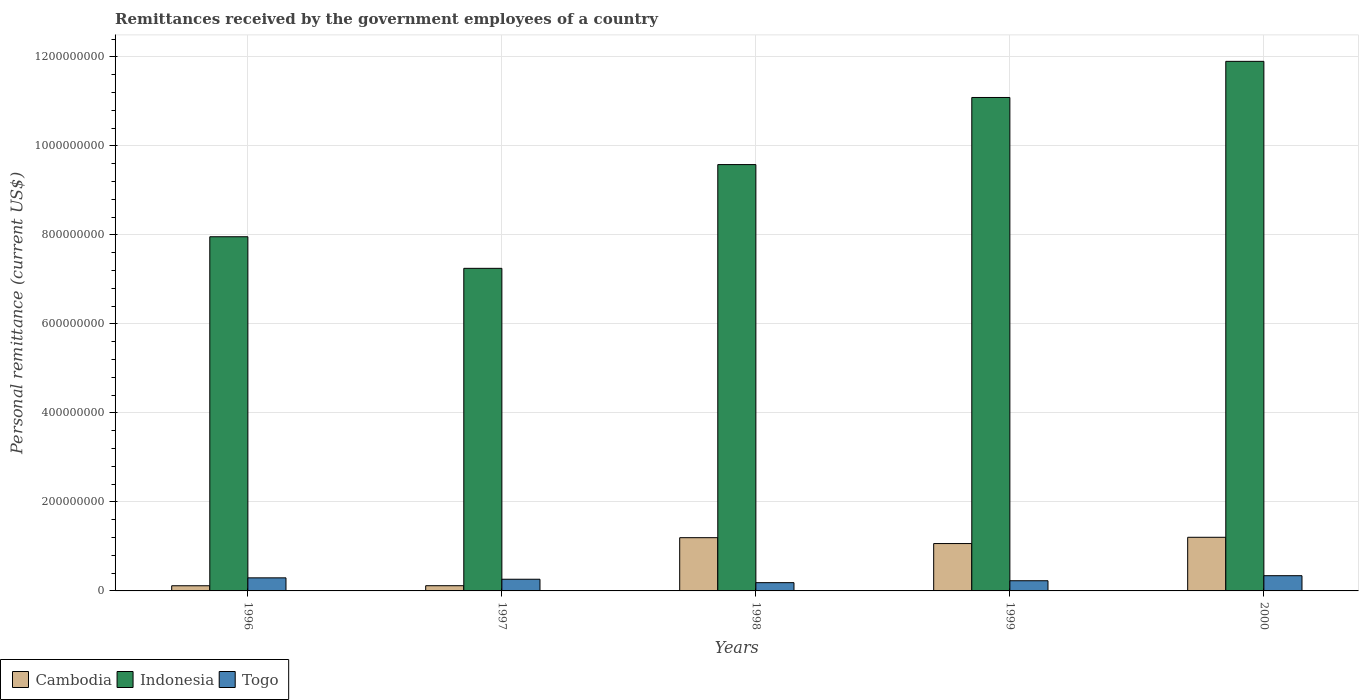How many groups of bars are there?
Offer a terse response. 5. Are the number of bars on each tick of the X-axis equal?
Make the answer very short. Yes. How many bars are there on the 3rd tick from the right?
Your answer should be compact. 3. What is the label of the 1st group of bars from the left?
Make the answer very short. 1996. In how many cases, is the number of bars for a given year not equal to the number of legend labels?
Keep it short and to the point. 0. What is the remittances received by the government employees in Togo in 1996?
Your response must be concise. 2.94e+07. Across all years, what is the maximum remittances received by the government employees in Togo?
Make the answer very short. 3.42e+07. Across all years, what is the minimum remittances received by the government employees in Indonesia?
Your answer should be very brief. 7.25e+08. What is the total remittances received by the government employees in Togo in the graph?
Your response must be concise. 1.31e+08. What is the difference between the remittances received by the government employees in Cambodia in 1996 and that in 1999?
Keep it short and to the point. -9.48e+07. What is the difference between the remittances received by the government employees in Togo in 1998 and the remittances received by the government employees in Cambodia in 1999?
Ensure brevity in your answer.  -8.79e+07. What is the average remittances received by the government employees in Cambodia per year?
Make the answer very short. 7.40e+07. In the year 1997, what is the difference between the remittances received by the government employees in Cambodia and remittances received by the government employees in Togo?
Offer a terse response. -1.46e+07. In how many years, is the remittances received by the government employees in Togo greater than 1160000000 US$?
Offer a very short reply. 0. What is the ratio of the remittances received by the government employees in Togo in 1996 to that in 1999?
Provide a succinct answer. 1.28. Is the remittances received by the government employees in Togo in 1999 less than that in 2000?
Offer a very short reply. Yes. What is the difference between the highest and the second highest remittances received by the government employees in Togo?
Offer a very short reply. 4.86e+06. What is the difference between the highest and the lowest remittances received by the government employees in Cambodia?
Offer a very short reply. 1.09e+08. Is the sum of the remittances received by the government employees in Cambodia in 1996 and 2000 greater than the maximum remittances received by the government employees in Togo across all years?
Offer a very short reply. Yes. What does the 3rd bar from the right in 1999 represents?
Provide a succinct answer. Cambodia. How many years are there in the graph?
Your answer should be compact. 5. Are the values on the major ticks of Y-axis written in scientific E-notation?
Offer a terse response. No. Does the graph contain any zero values?
Your answer should be very brief. No. How many legend labels are there?
Offer a very short reply. 3. How are the legend labels stacked?
Give a very brief answer. Horizontal. What is the title of the graph?
Give a very brief answer. Remittances received by the government employees of a country. Does "Iceland" appear as one of the legend labels in the graph?
Offer a terse response. No. What is the label or title of the Y-axis?
Offer a terse response. Personal remittance (current US$). What is the Personal remittance (current US$) of Cambodia in 1996?
Make the answer very short. 1.16e+07. What is the Personal remittance (current US$) in Indonesia in 1996?
Your response must be concise. 7.96e+08. What is the Personal remittance (current US$) in Togo in 1996?
Your answer should be compact. 2.94e+07. What is the Personal remittance (current US$) of Cambodia in 1997?
Provide a succinct answer. 1.17e+07. What is the Personal remittance (current US$) in Indonesia in 1997?
Your answer should be very brief. 7.25e+08. What is the Personal remittance (current US$) of Togo in 1997?
Offer a very short reply. 2.63e+07. What is the Personal remittance (current US$) of Cambodia in 1998?
Ensure brevity in your answer.  1.20e+08. What is the Personal remittance (current US$) of Indonesia in 1998?
Make the answer very short. 9.58e+08. What is the Personal remittance (current US$) in Togo in 1998?
Your answer should be very brief. 1.86e+07. What is the Personal remittance (current US$) of Cambodia in 1999?
Your answer should be very brief. 1.06e+08. What is the Personal remittance (current US$) of Indonesia in 1999?
Keep it short and to the point. 1.11e+09. What is the Personal remittance (current US$) in Togo in 1999?
Your answer should be compact. 2.29e+07. What is the Personal remittance (current US$) in Cambodia in 2000?
Provide a succinct answer. 1.21e+08. What is the Personal remittance (current US$) of Indonesia in 2000?
Your response must be concise. 1.19e+09. What is the Personal remittance (current US$) of Togo in 2000?
Ensure brevity in your answer.  3.42e+07. Across all years, what is the maximum Personal remittance (current US$) of Cambodia?
Your answer should be compact. 1.21e+08. Across all years, what is the maximum Personal remittance (current US$) in Indonesia?
Provide a succinct answer. 1.19e+09. Across all years, what is the maximum Personal remittance (current US$) of Togo?
Give a very brief answer. 3.42e+07. Across all years, what is the minimum Personal remittance (current US$) of Cambodia?
Ensure brevity in your answer.  1.16e+07. Across all years, what is the minimum Personal remittance (current US$) in Indonesia?
Provide a succinct answer. 7.25e+08. Across all years, what is the minimum Personal remittance (current US$) in Togo?
Offer a very short reply. 1.86e+07. What is the total Personal remittance (current US$) of Cambodia in the graph?
Keep it short and to the point. 3.70e+08. What is the total Personal remittance (current US$) of Indonesia in the graph?
Your answer should be very brief. 4.78e+09. What is the total Personal remittance (current US$) in Togo in the graph?
Your answer should be very brief. 1.31e+08. What is the difference between the Personal remittance (current US$) of Cambodia in 1996 and that in 1997?
Your answer should be compact. -1.00e+05. What is the difference between the Personal remittance (current US$) of Indonesia in 1996 and that in 1997?
Your response must be concise. 7.10e+07. What is the difference between the Personal remittance (current US$) of Togo in 1996 and that in 1997?
Provide a short and direct response. 3.11e+06. What is the difference between the Personal remittance (current US$) in Cambodia in 1996 and that in 1998?
Provide a short and direct response. -1.08e+08. What is the difference between the Personal remittance (current US$) in Indonesia in 1996 and that in 1998?
Give a very brief answer. -1.62e+08. What is the difference between the Personal remittance (current US$) in Togo in 1996 and that in 1998?
Keep it short and to the point. 1.08e+07. What is the difference between the Personal remittance (current US$) of Cambodia in 1996 and that in 1999?
Provide a short and direct response. -9.48e+07. What is the difference between the Personal remittance (current US$) in Indonesia in 1996 and that in 1999?
Provide a succinct answer. -3.13e+08. What is the difference between the Personal remittance (current US$) in Togo in 1996 and that in 1999?
Your answer should be very brief. 6.51e+06. What is the difference between the Personal remittance (current US$) of Cambodia in 1996 and that in 2000?
Ensure brevity in your answer.  -1.09e+08. What is the difference between the Personal remittance (current US$) in Indonesia in 1996 and that in 2000?
Your response must be concise. -3.94e+08. What is the difference between the Personal remittance (current US$) of Togo in 1996 and that in 2000?
Your answer should be compact. -4.86e+06. What is the difference between the Personal remittance (current US$) in Cambodia in 1997 and that in 1998?
Your response must be concise. -1.08e+08. What is the difference between the Personal remittance (current US$) in Indonesia in 1997 and that in 1998?
Give a very brief answer. -2.33e+08. What is the difference between the Personal remittance (current US$) of Togo in 1997 and that in 1998?
Keep it short and to the point. 7.69e+06. What is the difference between the Personal remittance (current US$) in Cambodia in 1997 and that in 1999?
Make the answer very short. -9.47e+07. What is the difference between the Personal remittance (current US$) in Indonesia in 1997 and that in 1999?
Offer a very short reply. -3.84e+08. What is the difference between the Personal remittance (current US$) in Togo in 1997 and that in 1999?
Give a very brief answer. 3.40e+06. What is the difference between the Personal remittance (current US$) in Cambodia in 1997 and that in 2000?
Keep it short and to the point. -1.09e+08. What is the difference between the Personal remittance (current US$) in Indonesia in 1997 and that in 2000?
Your response must be concise. -4.65e+08. What is the difference between the Personal remittance (current US$) of Togo in 1997 and that in 2000?
Make the answer very short. -7.97e+06. What is the difference between the Personal remittance (current US$) in Cambodia in 1998 and that in 1999?
Provide a short and direct response. 1.32e+07. What is the difference between the Personal remittance (current US$) of Indonesia in 1998 and that in 1999?
Your response must be concise. -1.51e+08. What is the difference between the Personal remittance (current US$) in Togo in 1998 and that in 1999?
Ensure brevity in your answer.  -4.29e+06. What is the difference between the Personal remittance (current US$) of Cambodia in 1998 and that in 2000?
Offer a terse response. -8.59e+05. What is the difference between the Personal remittance (current US$) in Indonesia in 1998 and that in 2000?
Your answer should be compact. -2.32e+08. What is the difference between the Personal remittance (current US$) in Togo in 1998 and that in 2000?
Make the answer very short. -1.57e+07. What is the difference between the Personal remittance (current US$) of Cambodia in 1999 and that in 2000?
Offer a terse response. -1.41e+07. What is the difference between the Personal remittance (current US$) of Indonesia in 1999 and that in 2000?
Your response must be concise. -8.12e+07. What is the difference between the Personal remittance (current US$) in Togo in 1999 and that in 2000?
Offer a very short reply. -1.14e+07. What is the difference between the Personal remittance (current US$) in Cambodia in 1996 and the Personal remittance (current US$) in Indonesia in 1997?
Your response must be concise. -7.13e+08. What is the difference between the Personal remittance (current US$) of Cambodia in 1996 and the Personal remittance (current US$) of Togo in 1997?
Give a very brief answer. -1.47e+07. What is the difference between the Personal remittance (current US$) in Indonesia in 1996 and the Personal remittance (current US$) in Togo in 1997?
Your answer should be compact. 7.70e+08. What is the difference between the Personal remittance (current US$) in Cambodia in 1996 and the Personal remittance (current US$) in Indonesia in 1998?
Offer a very short reply. -9.47e+08. What is the difference between the Personal remittance (current US$) of Cambodia in 1996 and the Personal remittance (current US$) of Togo in 1998?
Give a very brief answer. -6.97e+06. What is the difference between the Personal remittance (current US$) in Indonesia in 1996 and the Personal remittance (current US$) in Togo in 1998?
Provide a short and direct response. 7.77e+08. What is the difference between the Personal remittance (current US$) in Cambodia in 1996 and the Personal remittance (current US$) in Indonesia in 1999?
Offer a terse response. -1.10e+09. What is the difference between the Personal remittance (current US$) in Cambodia in 1996 and the Personal remittance (current US$) in Togo in 1999?
Keep it short and to the point. -1.13e+07. What is the difference between the Personal remittance (current US$) of Indonesia in 1996 and the Personal remittance (current US$) of Togo in 1999?
Keep it short and to the point. 7.73e+08. What is the difference between the Personal remittance (current US$) of Cambodia in 1996 and the Personal remittance (current US$) of Indonesia in 2000?
Ensure brevity in your answer.  -1.18e+09. What is the difference between the Personal remittance (current US$) of Cambodia in 1996 and the Personal remittance (current US$) of Togo in 2000?
Make the answer very short. -2.26e+07. What is the difference between the Personal remittance (current US$) of Indonesia in 1996 and the Personal remittance (current US$) of Togo in 2000?
Provide a succinct answer. 7.62e+08. What is the difference between the Personal remittance (current US$) of Cambodia in 1997 and the Personal remittance (current US$) of Indonesia in 1998?
Keep it short and to the point. -9.46e+08. What is the difference between the Personal remittance (current US$) of Cambodia in 1997 and the Personal remittance (current US$) of Togo in 1998?
Your answer should be compact. -6.87e+06. What is the difference between the Personal remittance (current US$) in Indonesia in 1997 and the Personal remittance (current US$) in Togo in 1998?
Your answer should be very brief. 7.06e+08. What is the difference between the Personal remittance (current US$) of Cambodia in 1997 and the Personal remittance (current US$) of Indonesia in 1999?
Your answer should be very brief. -1.10e+09. What is the difference between the Personal remittance (current US$) of Cambodia in 1997 and the Personal remittance (current US$) of Togo in 1999?
Provide a succinct answer. -1.12e+07. What is the difference between the Personal remittance (current US$) of Indonesia in 1997 and the Personal remittance (current US$) of Togo in 1999?
Give a very brief answer. 7.02e+08. What is the difference between the Personal remittance (current US$) of Cambodia in 1997 and the Personal remittance (current US$) of Indonesia in 2000?
Provide a succinct answer. -1.18e+09. What is the difference between the Personal remittance (current US$) of Cambodia in 1997 and the Personal remittance (current US$) of Togo in 2000?
Keep it short and to the point. -2.25e+07. What is the difference between the Personal remittance (current US$) in Indonesia in 1997 and the Personal remittance (current US$) in Togo in 2000?
Provide a short and direct response. 6.91e+08. What is the difference between the Personal remittance (current US$) in Cambodia in 1998 and the Personal remittance (current US$) in Indonesia in 1999?
Keep it short and to the point. -9.89e+08. What is the difference between the Personal remittance (current US$) of Cambodia in 1998 and the Personal remittance (current US$) of Togo in 1999?
Your answer should be very brief. 9.68e+07. What is the difference between the Personal remittance (current US$) in Indonesia in 1998 and the Personal remittance (current US$) in Togo in 1999?
Make the answer very short. 9.35e+08. What is the difference between the Personal remittance (current US$) of Cambodia in 1998 and the Personal remittance (current US$) of Indonesia in 2000?
Offer a very short reply. -1.07e+09. What is the difference between the Personal remittance (current US$) of Cambodia in 1998 and the Personal remittance (current US$) of Togo in 2000?
Make the answer very short. 8.54e+07. What is the difference between the Personal remittance (current US$) of Indonesia in 1998 and the Personal remittance (current US$) of Togo in 2000?
Give a very brief answer. 9.24e+08. What is the difference between the Personal remittance (current US$) in Cambodia in 1999 and the Personal remittance (current US$) in Indonesia in 2000?
Your response must be concise. -1.08e+09. What is the difference between the Personal remittance (current US$) in Cambodia in 1999 and the Personal remittance (current US$) in Togo in 2000?
Make the answer very short. 7.22e+07. What is the difference between the Personal remittance (current US$) of Indonesia in 1999 and the Personal remittance (current US$) of Togo in 2000?
Offer a terse response. 1.07e+09. What is the average Personal remittance (current US$) in Cambodia per year?
Give a very brief answer. 7.40e+07. What is the average Personal remittance (current US$) in Indonesia per year?
Offer a terse response. 9.56e+08. What is the average Personal remittance (current US$) in Togo per year?
Provide a short and direct response. 2.63e+07. In the year 1996, what is the difference between the Personal remittance (current US$) in Cambodia and Personal remittance (current US$) in Indonesia?
Keep it short and to the point. -7.84e+08. In the year 1996, what is the difference between the Personal remittance (current US$) in Cambodia and Personal remittance (current US$) in Togo?
Give a very brief answer. -1.78e+07. In the year 1996, what is the difference between the Personal remittance (current US$) of Indonesia and Personal remittance (current US$) of Togo?
Keep it short and to the point. 7.67e+08. In the year 1997, what is the difference between the Personal remittance (current US$) of Cambodia and Personal remittance (current US$) of Indonesia?
Offer a terse response. -7.13e+08. In the year 1997, what is the difference between the Personal remittance (current US$) in Cambodia and Personal remittance (current US$) in Togo?
Your answer should be compact. -1.46e+07. In the year 1997, what is the difference between the Personal remittance (current US$) of Indonesia and Personal remittance (current US$) of Togo?
Your response must be concise. 6.99e+08. In the year 1998, what is the difference between the Personal remittance (current US$) in Cambodia and Personal remittance (current US$) in Indonesia?
Your answer should be compact. -8.39e+08. In the year 1998, what is the difference between the Personal remittance (current US$) in Cambodia and Personal remittance (current US$) in Togo?
Your answer should be compact. 1.01e+08. In the year 1998, what is the difference between the Personal remittance (current US$) of Indonesia and Personal remittance (current US$) of Togo?
Offer a very short reply. 9.40e+08. In the year 1999, what is the difference between the Personal remittance (current US$) in Cambodia and Personal remittance (current US$) in Indonesia?
Your answer should be very brief. -1.00e+09. In the year 1999, what is the difference between the Personal remittance (current US$) in Cambodia and Personal remittance (current US$) in Togo?
Make the answer very short. 8.36e+07. In the year 1999, what is the difference between the Personal remittance (current US$) of Indonesia and Personal remittance (current US$) of Togo?
Make the answer very short. 1.09e+09. In the year 2000, what is the difference between the Personal remittance (current US$) of Cambodia and Personal remittance (current US$) of Indonesia?
Give a very brief answer. -1.07e+09. In the year 2000, what is the difference between the Personal remittance (current US$) in Cambodia and Personal remittance (current US$) in Togo?
Provide a short and direct response. 8.63e+07. In the year 2000, what is the difference between the Personal remittance (current US$) in Indonesia and Personal remittance (current US$) in Togo?
Give a very brief answer. 1.16e+09. What is the ratio of the Personal remittance (current US$) in Indonesia in 1996 to that in 1997?
Offer a terse response. 1.1. What is the ratio of the Personal remittance (current US$) of Togo in 1996 to that in 1997?
Offer a very short reply. 1.12. What is the ratio of the Personal remittance (current US$) of Cambodia in 1996 to that in 1998?
Your answer should be very brief. 0.1. What is the ratio of the Personal remittance (current US$) in Indonesia in 1996 to that in 1998?
Provide a succinct answer. 0.83. What is the ratio of the Personal remittance (current US$) in Togo in 1996 to that in 1998?
Provide a succinct answer. 1.58. What is the ratio of the Personal remittance (current US$) in Cambodia in 1996 to that in 1999?
Your answer should be compact. 0.11. What is the ratio of the Personal remittance (current US$) of Indonesia in 1996 to that in 1999?
Your answer should be very brief. 0.72. What is the ratio of the Personal remittance (current US$) in Togo in 1996 to that in 1999?
Provide a succinct answer. 1.28. What is the ratio of the Personal remittance (current US$) in Cambodia in 1996 to that in 2000?
Keep it short and to the point. 0.1. What is the ratio of the Personal remittance (current US$) of Indonesia in 1996 to that in 2000?
Provide a succinct answer. 0.67. What is the ratio of the Personal remittance (current US$) in Togo in 1996 to that in 2000?
Provide a succinct answer. 0.86. What is the ratio of the Personal remittance (current US$) in Cambodia in 1997 to that in 1998?
Make the answer very short. 0.1. What is the ratio of the Personal remittance (current US$) in Indonesia in 1997 to that in 1998?
Ensure brevity in your answer.  0.76. What is the ratio of the Personal remittance (current US$) of Togo in 1997 to that in 1998?
Your response must be concise. 1.41. What is the ratio of the Personal remittance (current US$) of Cambodia in 1997 to that in 1999?
Give a very brief answer. 0.11. What is the ratio of the Personal remittance (current US$) in Indonesia in 1997 to that in 1999?
Provide a succinct answer. 0.65. What is the ratio of the Personal remittance (current US$) of Togo in 1997 to that in 1999?
Your response must be concise. 1.15. What is the ratio of the Personal remittance (current US$) in Cambodia in 1997 to that in 2000?
Keep it short and to the point. 0.1. What is the ratio of the Personal remittance (current US$) in Indonesia in 1997 to that in 2000?
Provide a succinct answer. 0.61. What is the ratio of the Personal remittance (current US$) in Togo in 1997 to that in 2000?
Give a very brief answer. 0.77. What is the ratio of the Personal remittance (current US$) in Cambodia in 1998 to that in 1999?
Provide a short and direct response. 1.12. What is the ratio of the Personal remittance (current US$) of Indonesia in 1998 to that in 1999?
Give a very brief answer. 0.86. What is the ratio of the Personal remittance (current US$) of Togo in 1998 to that in 1999?
Keep it short and to the point. 0.81. What is the ratio of the Personal remittance (current US$) in Indonesia in 1998 to that in 2000?
Provide a short and direct response. 0.81. What is the ratio of the Personal remittance (current US$) of Togo in 1998 to that in 2000?
Make the answer very short. 0.54. What is the ratio of the Personal remittance (current US$) of Cambodia in 1999 to that in 2000?
Give a very brief answer. 0.88. What is the ratio of the Personal remittance (current US$) of Indonesia in 1999 to that in 2000?
Make the answer very short. 0.93. What is the ratio of the Personal remittance (current US$) in Togo in 1999 to that in 2000?
Your response must be concise. 0.67. What is the difference between the highest and the second highest Personal remittance (current US$) of Cambodia?
Provide a short and direct response. 8.59e+05. What is the difference between the highest and the second highest Personal remittance (current US$) in Indonesia?
Ensure brevity in your answer.  8.12e+07. What is the difference between the highest and the second highest Personal remittance (current US$) in Togo?
Offer a very short reply. 4.86e+06. What is the difference between the highest and the lowest Personal remittance (current US$) in Cambodia?
Give a very brief answer. 1.09e+08. What is the difference between the highest and the lowest Personal remittance (current US$) of Indonesia?
Provide a succinct answer. 4.65e+08. What is the difference between the highest and the lowest Personal remittance (current US$) in Togo?
Your answer should be compact. 1.57e+07. 